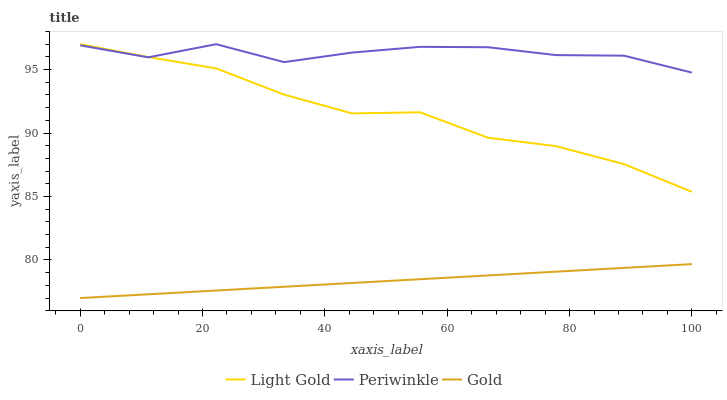Does Gold have the minimum area under the curve?
Answer yes or no. Yes. Does Periwinkle have the maximum area under the curve?
Answer yes or no. Yes. Does Light Gold have the minimum area under the curve?
Answer yes or no. No. Does Light Gold have the maximum area under the curve?
Answer yes or no. No. Is Gold the smoothest?
Answer yes or no. Yes. Is Periwinkle the roughest?
Answer yes or no. Yes. Is Light Gold the smoothest?
Answer yes or no. No. Is Light Gold the roughest?
Answer yes or no. No. Does Light Gold have the lowest value?
Answer yes or no. No. Does Light Gold have the highest value?
Answer yes or no. Yes. Does Gold have the highest value?
Answer yes or no. No. Is Gold less than Periwinkle?
Answer yes or no. Yes. Is Light Gold greater than Gold?
Answer yes or no. Yes. Does Light Gold intersect Periwinkle?
Answer yes or no. Yes. Is Light Gold less than Periwinkle?
Answer yes or no. No. Is Light Gold greater than Periwinkle?
Answer yes or no. No. Does Gold intersect Periwinkle?
Answer yes or no. No. 